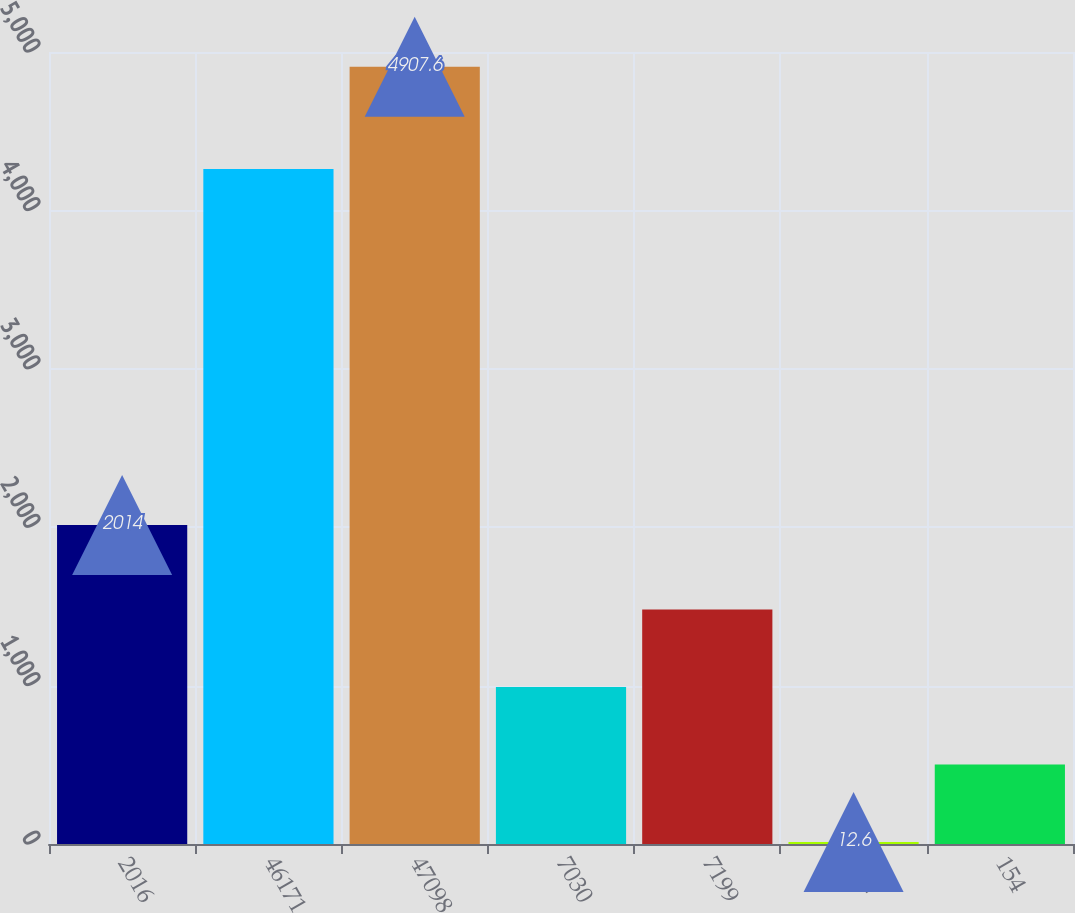<chart> <loc_0><loc_0><loc_500><loc_500><bar_chart><fcel>2016<fcel>46171<fcel>47098<fcel>7030<fcel>7199<fcel>152<fcel>154<nl><fcel>2014<fcel>4261.9<fcel>4907.6<fcel>991.6<fcel>1481.1<fcel>12.6<fcel>502.1<nl></chart> 